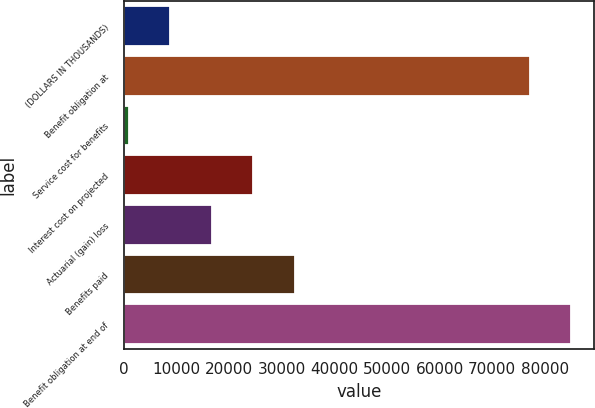Convert chart to OTSL. <chart><loc_0><loc_0><loc_500><loc_500><bar_chart><fcel>(DOLLARS IN THOUSANDS)<fcel>Benefit obligation at<fcel>Service cost for benefits<fcel>Interest cost on projected<fcel>Actuarial (gain) loss<fcel>Benefits paid<fcel>Benefit obligation at end of<nl><fcel>8751.3<fcel>77148<fcel>852<fcel>24549.9<fcel>16650.6<fcel>32449.2<fcel>85047.3<nl></chart> 